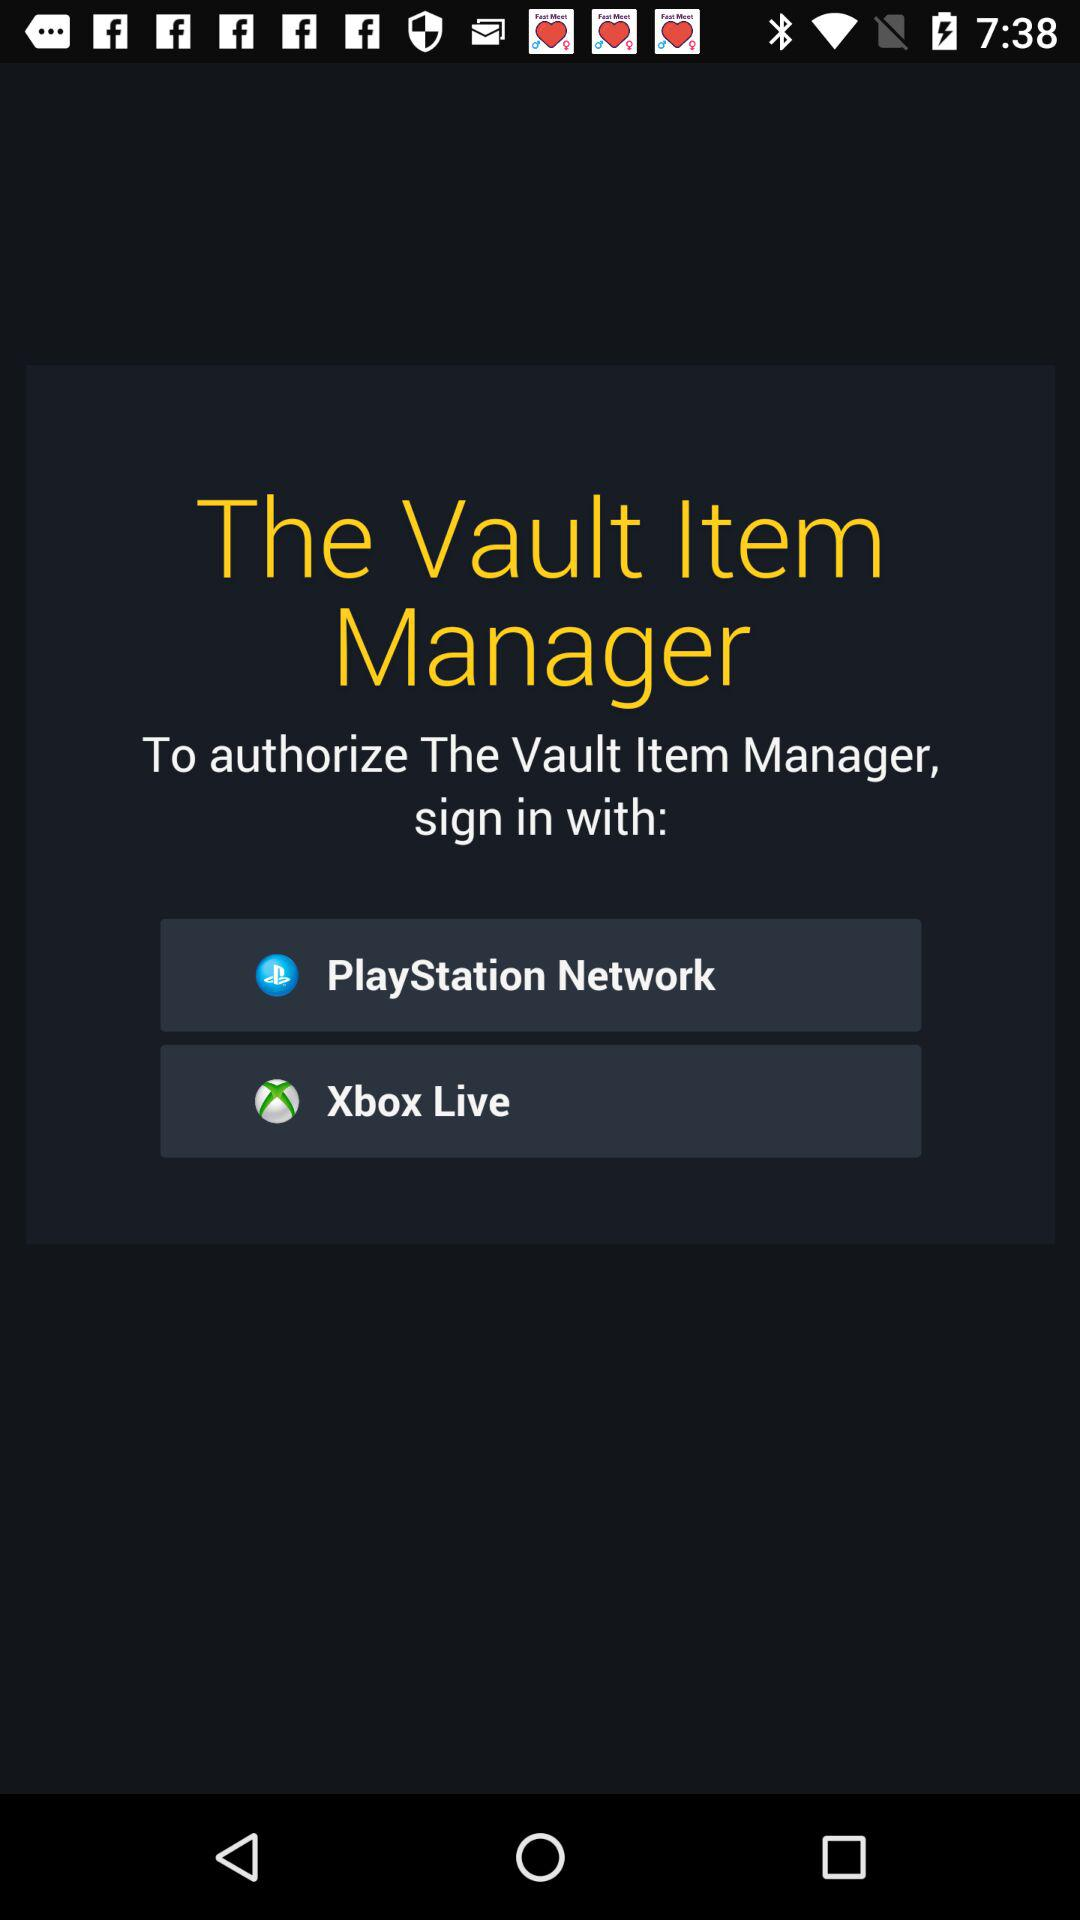What are the sign-in options available to authorize "The Vault Item Manager"? The sign-in options are "PlayStation Network" and "Xbox Live". 